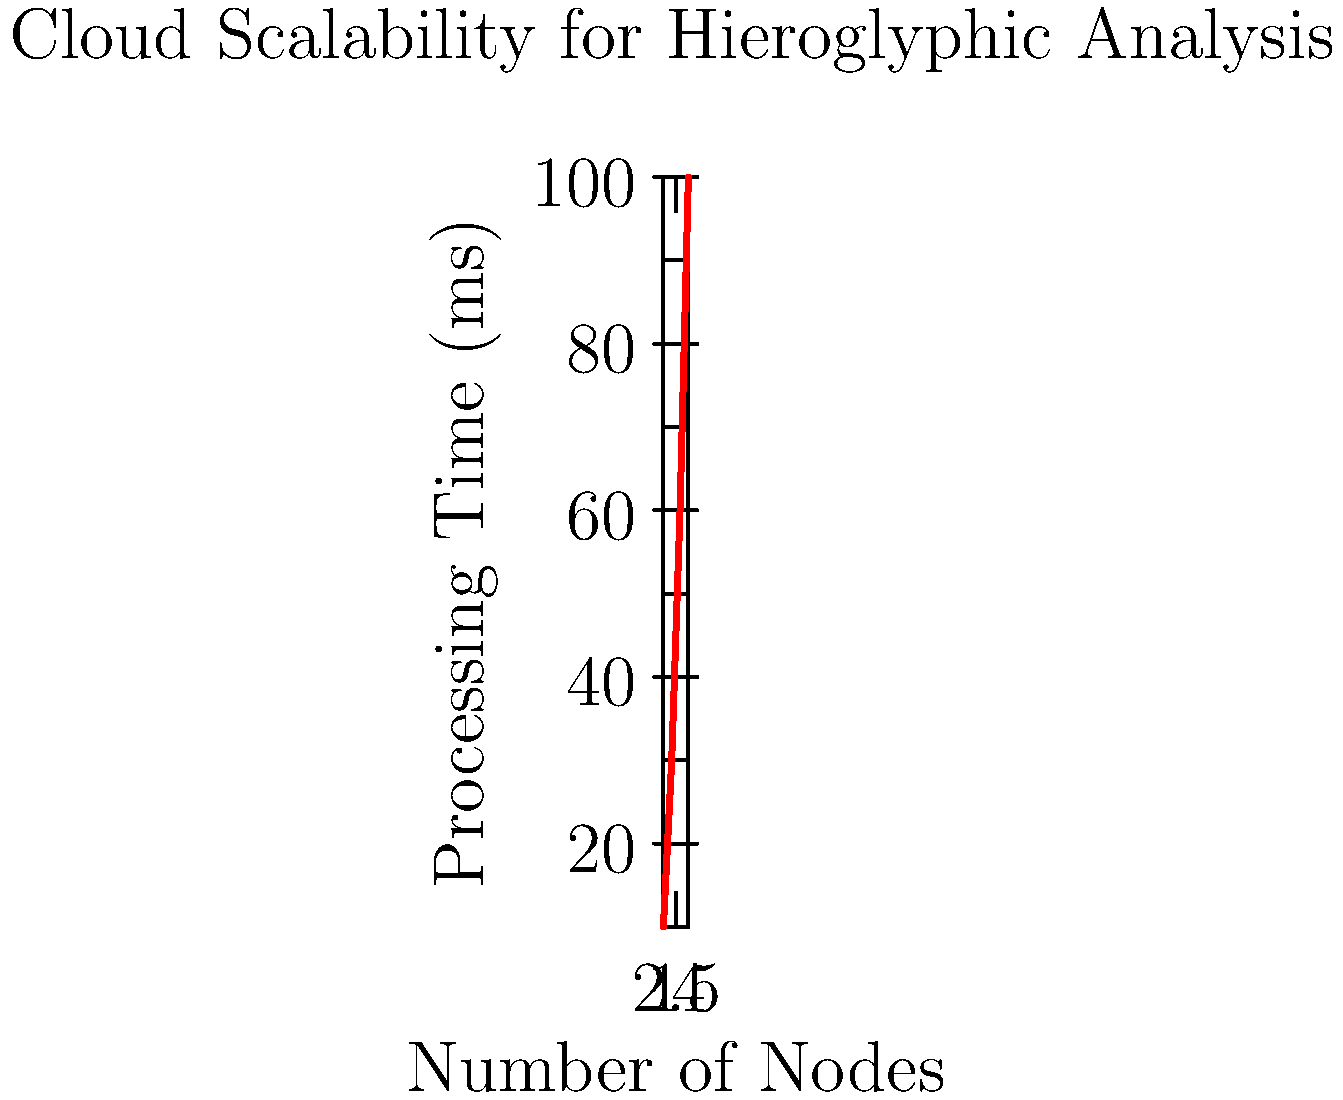Based on the graph showing the relationship between the number of nodes and processing time for hieroglyphic analysis, what type of scaling pattern does this cloud infrastructure exhibit, and how would you optimize it for better performance? To determine the scaling pattern and optimize the cloud infrastructure, let's analyze the graph step-by-step:

1. Observe the curve: The line is curved upward, indicating a non-linear relationship.

2. Identify the pattern: As the number of nodes increases, the processing time grows at an increasing rate. This suggests a sub-linear scaling pattern.

3. Calculate the scaling factor:
   - From 1 to 2 nodes: Time increases from 10ms to 30ms (3x increase)
   - From 2 to 3 nodes: Time increases from 30ms to 60ms (2x increase)
   - From 3 to 4 nodes: Time increases from 60ms to 100ms (1.67x increase)

4. Interpret the results: The decreasing scaling factor indicates diminishing returns as more nodes are added.

5. Identify the bottleneck: This pattern often suggests a communication overhead or resource contention issue.

6. Optimization strategies:
   a) Improve load balancing to distribute work more evenly across nodes.
   b) Optimize inter-node communication to reduce overhead.
   c) Use caching mechanisms to reduce redundant processing.
   d) Implement data partitioning to minimize data transfer between nodes.
   e) Consider using a message queue system for better task distribution.

The optimal solution is to implement a combination of these strategies, focusing on reducing communication overhead and improving resource utilization across nodes.
Answer: Sub-linear scaling; optimize load balancing, inter-node communication, caching, data partitioning, and task distribution. 